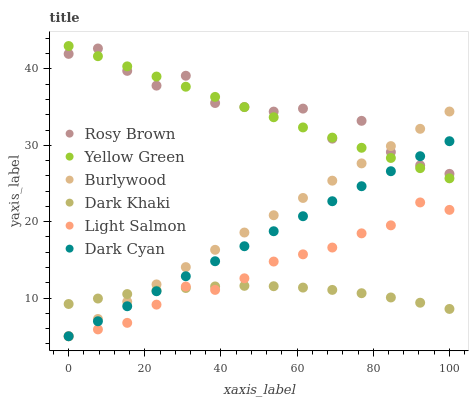Does Dark Khaki have the minimum area under the curve?
Answer yes or no. Yes. Does Rosy Brown have the maximum area under the curve?
Answer yes or no. Yes. Does Yellow Green have the minimum area under the curve?
Answer yes or no. No. Does Yellow Green have the maximum area under the curve?
Answer yes or no. No. Is Dark Cyan the smoothest?
Answer yes or no. Yes. Is Rosy Brown the roughest?
Answer yes or no. Yes. Is Yellow Green the smoothest?
Answer yes or no. No. Is Yellow Green the roughest?
Answer yes or no. No. Does Light Salmon have the lowest value?
Answer yes or no. Yes. Does Yellow Green have the lowest value?
Answer yes or no. No. Does Yellow Green have the highest value?
Answer yes or no. Yes. Does Burlywood have the highest value?
Answer yes or no. No. Is Light Salmon less than Yellow Green?
Answer yes or no. Yes. Is Rosy Brown greater than Light Salmon?
Answer yes or no. Yes. Does Yellow Green intersect Rosy Brown?
Answer yes or no. Yes. Is Yellow Green less than Rosy Brown?
Answer yes or no. No. Is Yellow Green greater than Rosy Brown?
Answer yes or no. No. Does Light Salmon intersect Yellow Green?
Answer yes or no. No. 